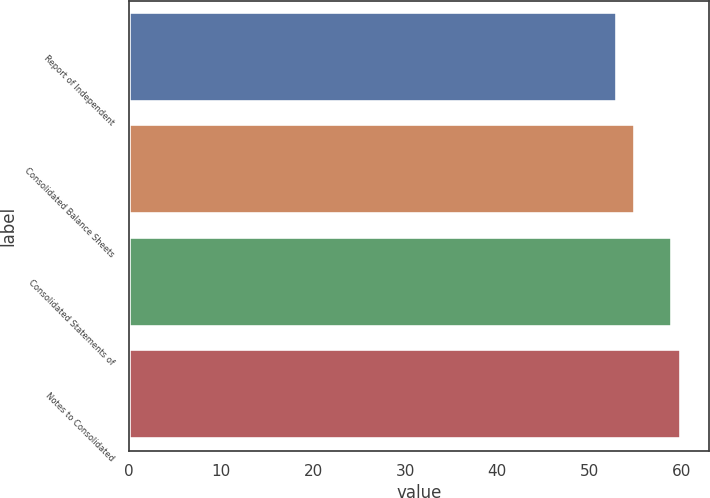Convert chart to OTSL. <chart><loc_0><loc_0><loc_500><loc_500><bar_chart><fcel>Report of Independent<fcel>Consolidated Balance Sheets<fcel>Consolidated Statements of<fcel>Notes to Consolidated<nl><fcel>53<fcel>55<fcel>59<fcel>60<nl></chart> 